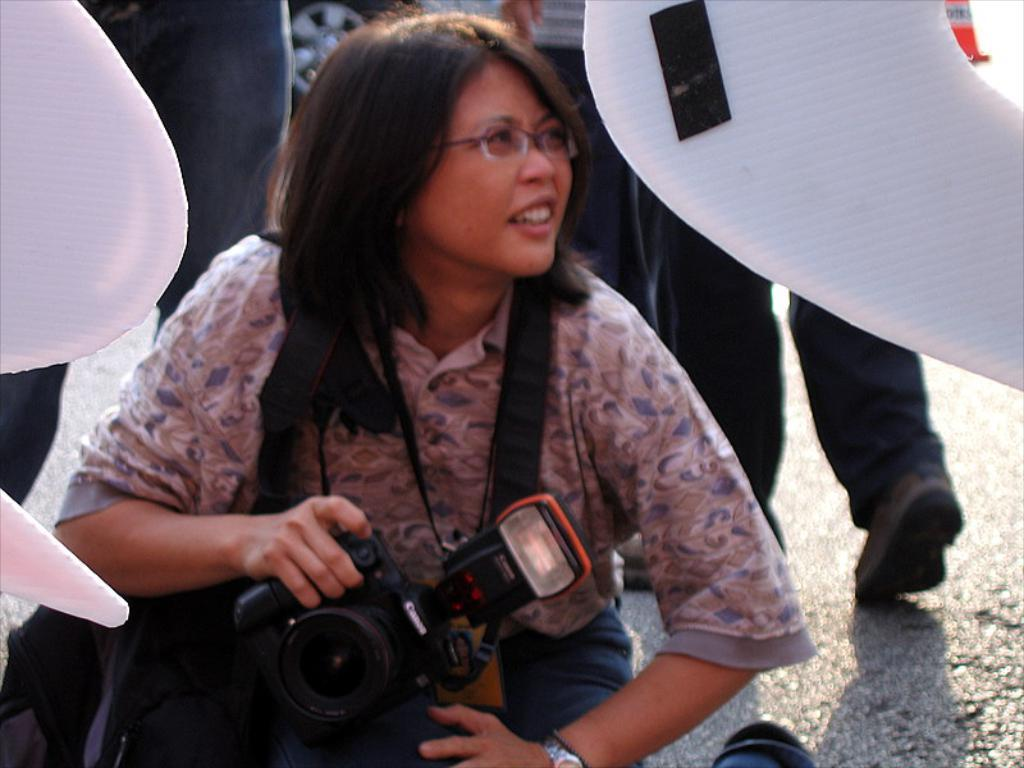Who is the main subject in the image? There is a woman in the image. What is the woman doing in the image? The woman is sitting on her legs. What object is the woman holding in her hand? The woman is holding a camera in her hand. Can you describe the people behind the woman? There are people behind the woman, but their specific actions or features are not mentioned in the provided facts. What type of ray is visible in the image? There is no ray present in the image. How many bikes can be seen in the image? There is no mention of bikes in the provided facts, so we cannot determine their presence or quantity in the image. 